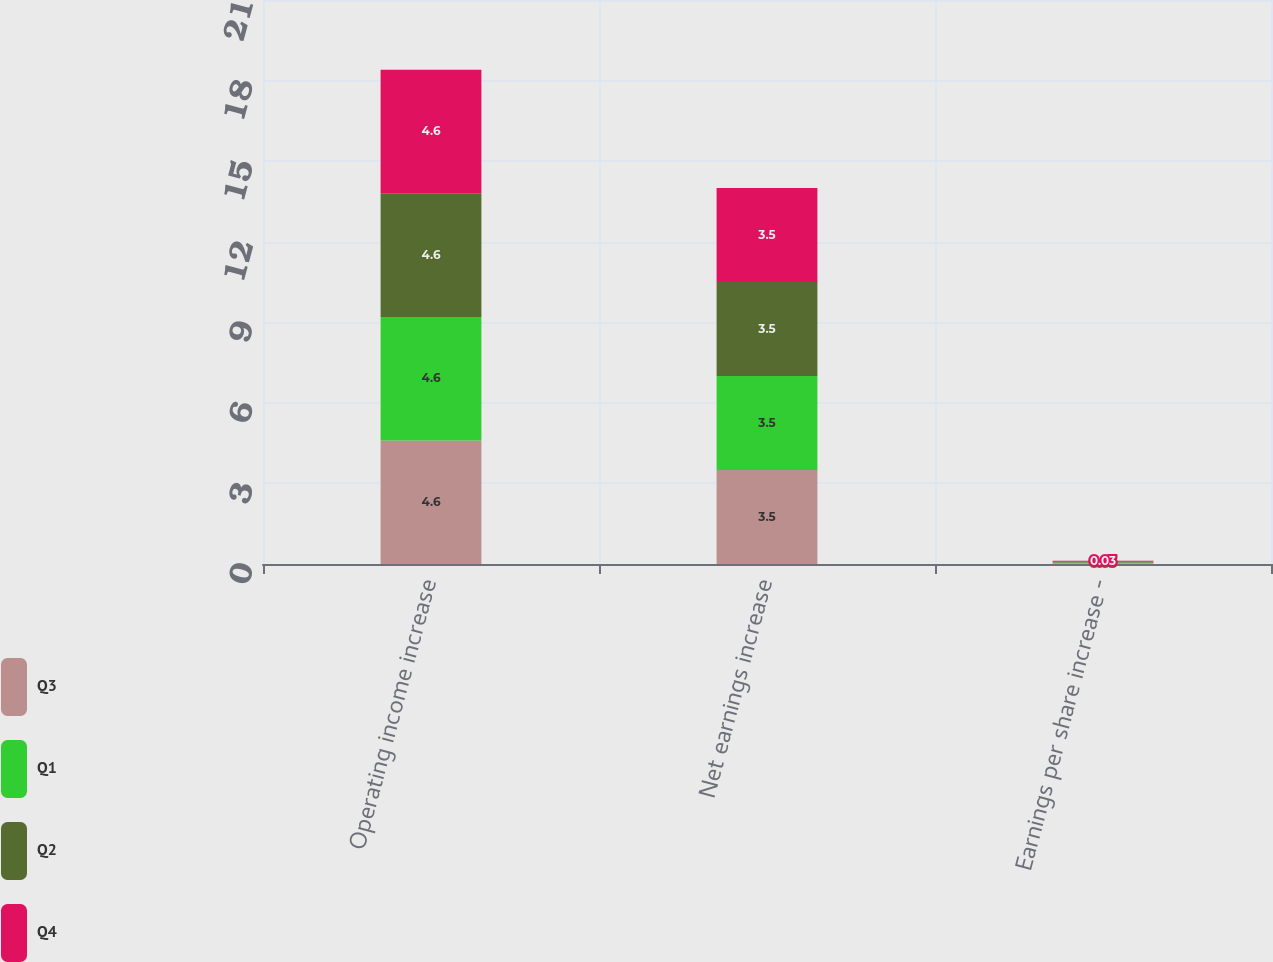<chart> <loc_0><loc_0><loc_500><loc_500><stacked_bar_chart><ecel><fcel>Operating income increase<fcel>Net earnings increase<fcel>Earnings per share increase -<nl><fcel>Q3<fcel>4.6<fcel>3.5<fcel>0.03<nl><fcel>Q1<fcel>4.6<fcel>3.5<fcel>0.03<nl><fcel>Q2<fcel>4.6<fcel>3.5<fcel>0.03<nl><fcel>Q4<fcel>4.6<fcel>3.5<fcel>0.03<nl></chart> 